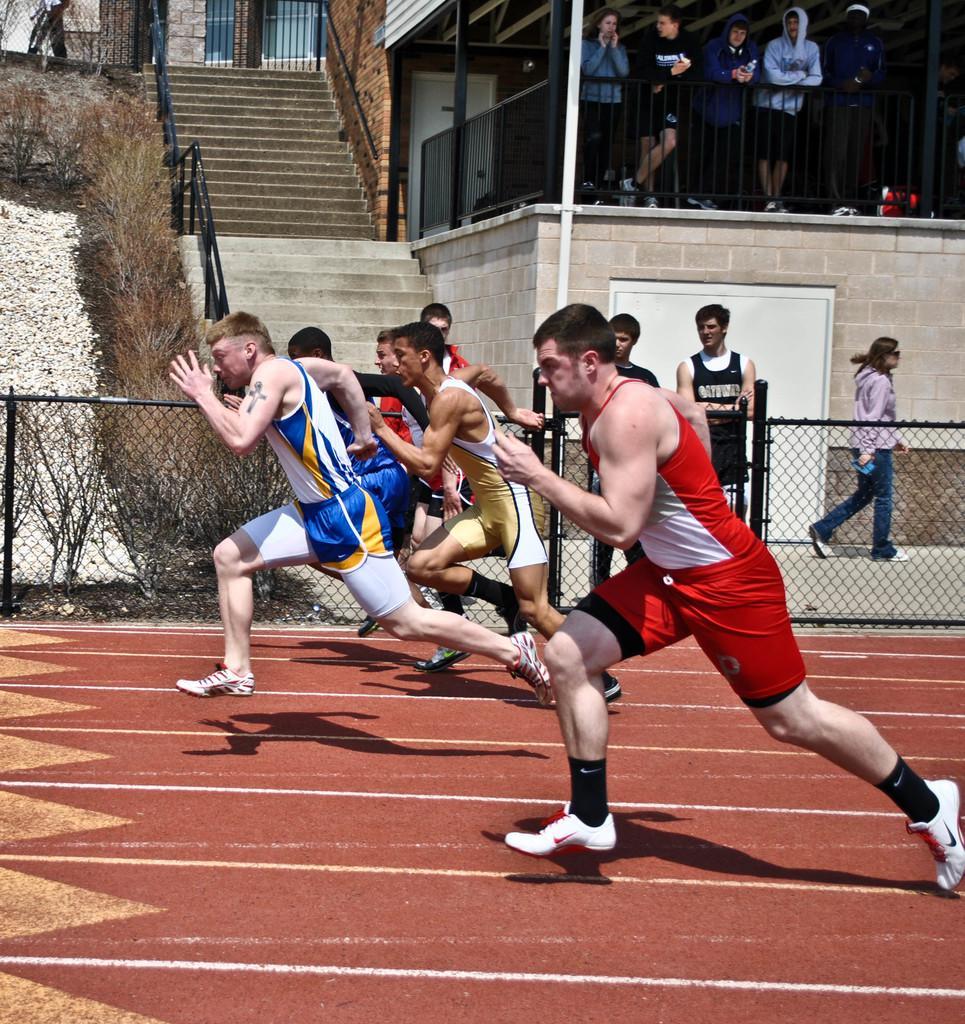Please provide a concise description of this image. In this Image I can see in the middle few persons are running, at the top there is a staircase. On the right side few persons are standing and observing this game. 